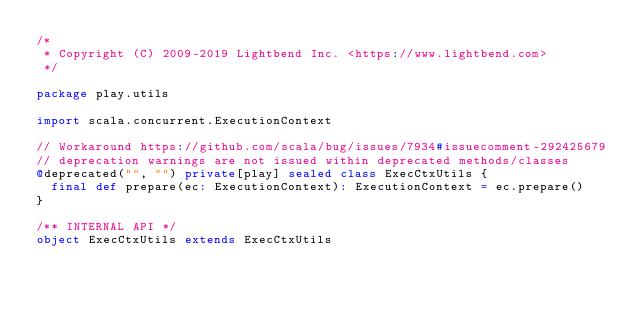<code> <loc_0><loc_0><loc_500><loc_500><_Scala_>/*
 * Copyright (C) 2009-2019 Lightbend Inc. <https://www.lightbend.com>
 */

package play.utils

import scala.concurrent.ExecutionContext

// Workaround https://github.com/scala/bug/issues/7934#issuecomment-292425679
// deprecation warnings are not issued within deprecated methods/classes
@deprecated("", "") private[play] sealed class ExecCtxUtils {
  final def prepare(ec: ExecutionContext): ExecutionContext = ec.prepare()
}

/** INTERNAL API */
object ExecCtxUtils extends ExecCtxUtils
</code> 